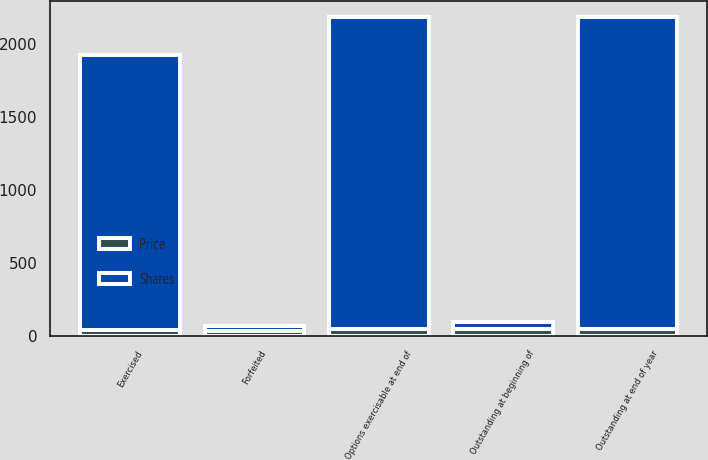Convert chart. <chart><loc_0><loc_0><loc_500><loc_500><stacked_bar_chart><ecel><fcel>Outstanding at beginning of<fcel>Exercised<fcel>Forfeited<fcel>Outstanding at end of year<fcel>Options exercisable at end of<nl><fcel>Shares<fcel>48.61<fcel>1890<fcel>31<fcel>2138<fcel>2137<nl><fcel>Price<fcel>44.53<fcel>40.06<fcel>36.02<fcel>48.61<fcel>48.62<nl></chart> 